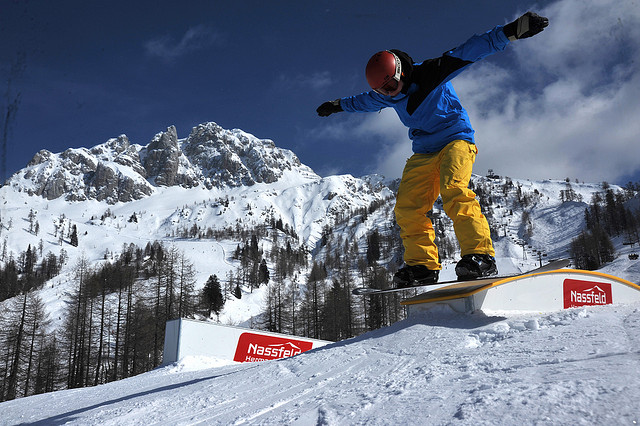Imagine a festival taking place in this location during winter. What activities and events might you envision? In a grand winter festival held in this stunning mountainous location, a myriad of activities and events would come to life, celebrating the magic of the season and the thrill of snow sports. There would be exhilarating snowboarding and skiing competitions, with athletes showcasing their skills and daring tricks. Warm, cozy lodges would host culinary delights featuring hot chocolate and local cuisine, providing a warm respite from the cold. Ice sculpting contests would add an artistic flair, while spirited snowball fights and toboggan races bring joy to both young and old. A highlight would be the evening's torchlight parade, where participants descend the slopes in a beautiful, glowing procession, culminating in a grand fireworks display illuminating the night sky against the snow-capped peaks. The festive atmosphere would be filled with laughter, music, and the enchanting aura of winter wonder. 